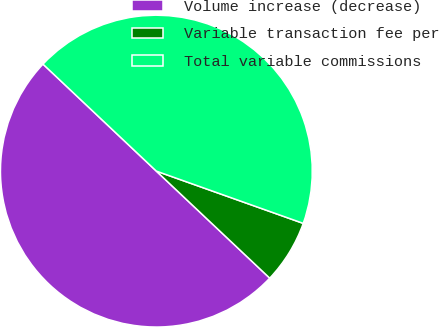Convert chart to OTSL. <chart><loc_0><loc_0><loc_500><loc_500><pie_chart><fcel>Volume increase (decrease)<fcel>Variable transaction fee per<fcel>Total variable commissions<nl><fcel>50.0%<fcel>6.6%<fcel>43.4%<nl></chart> 